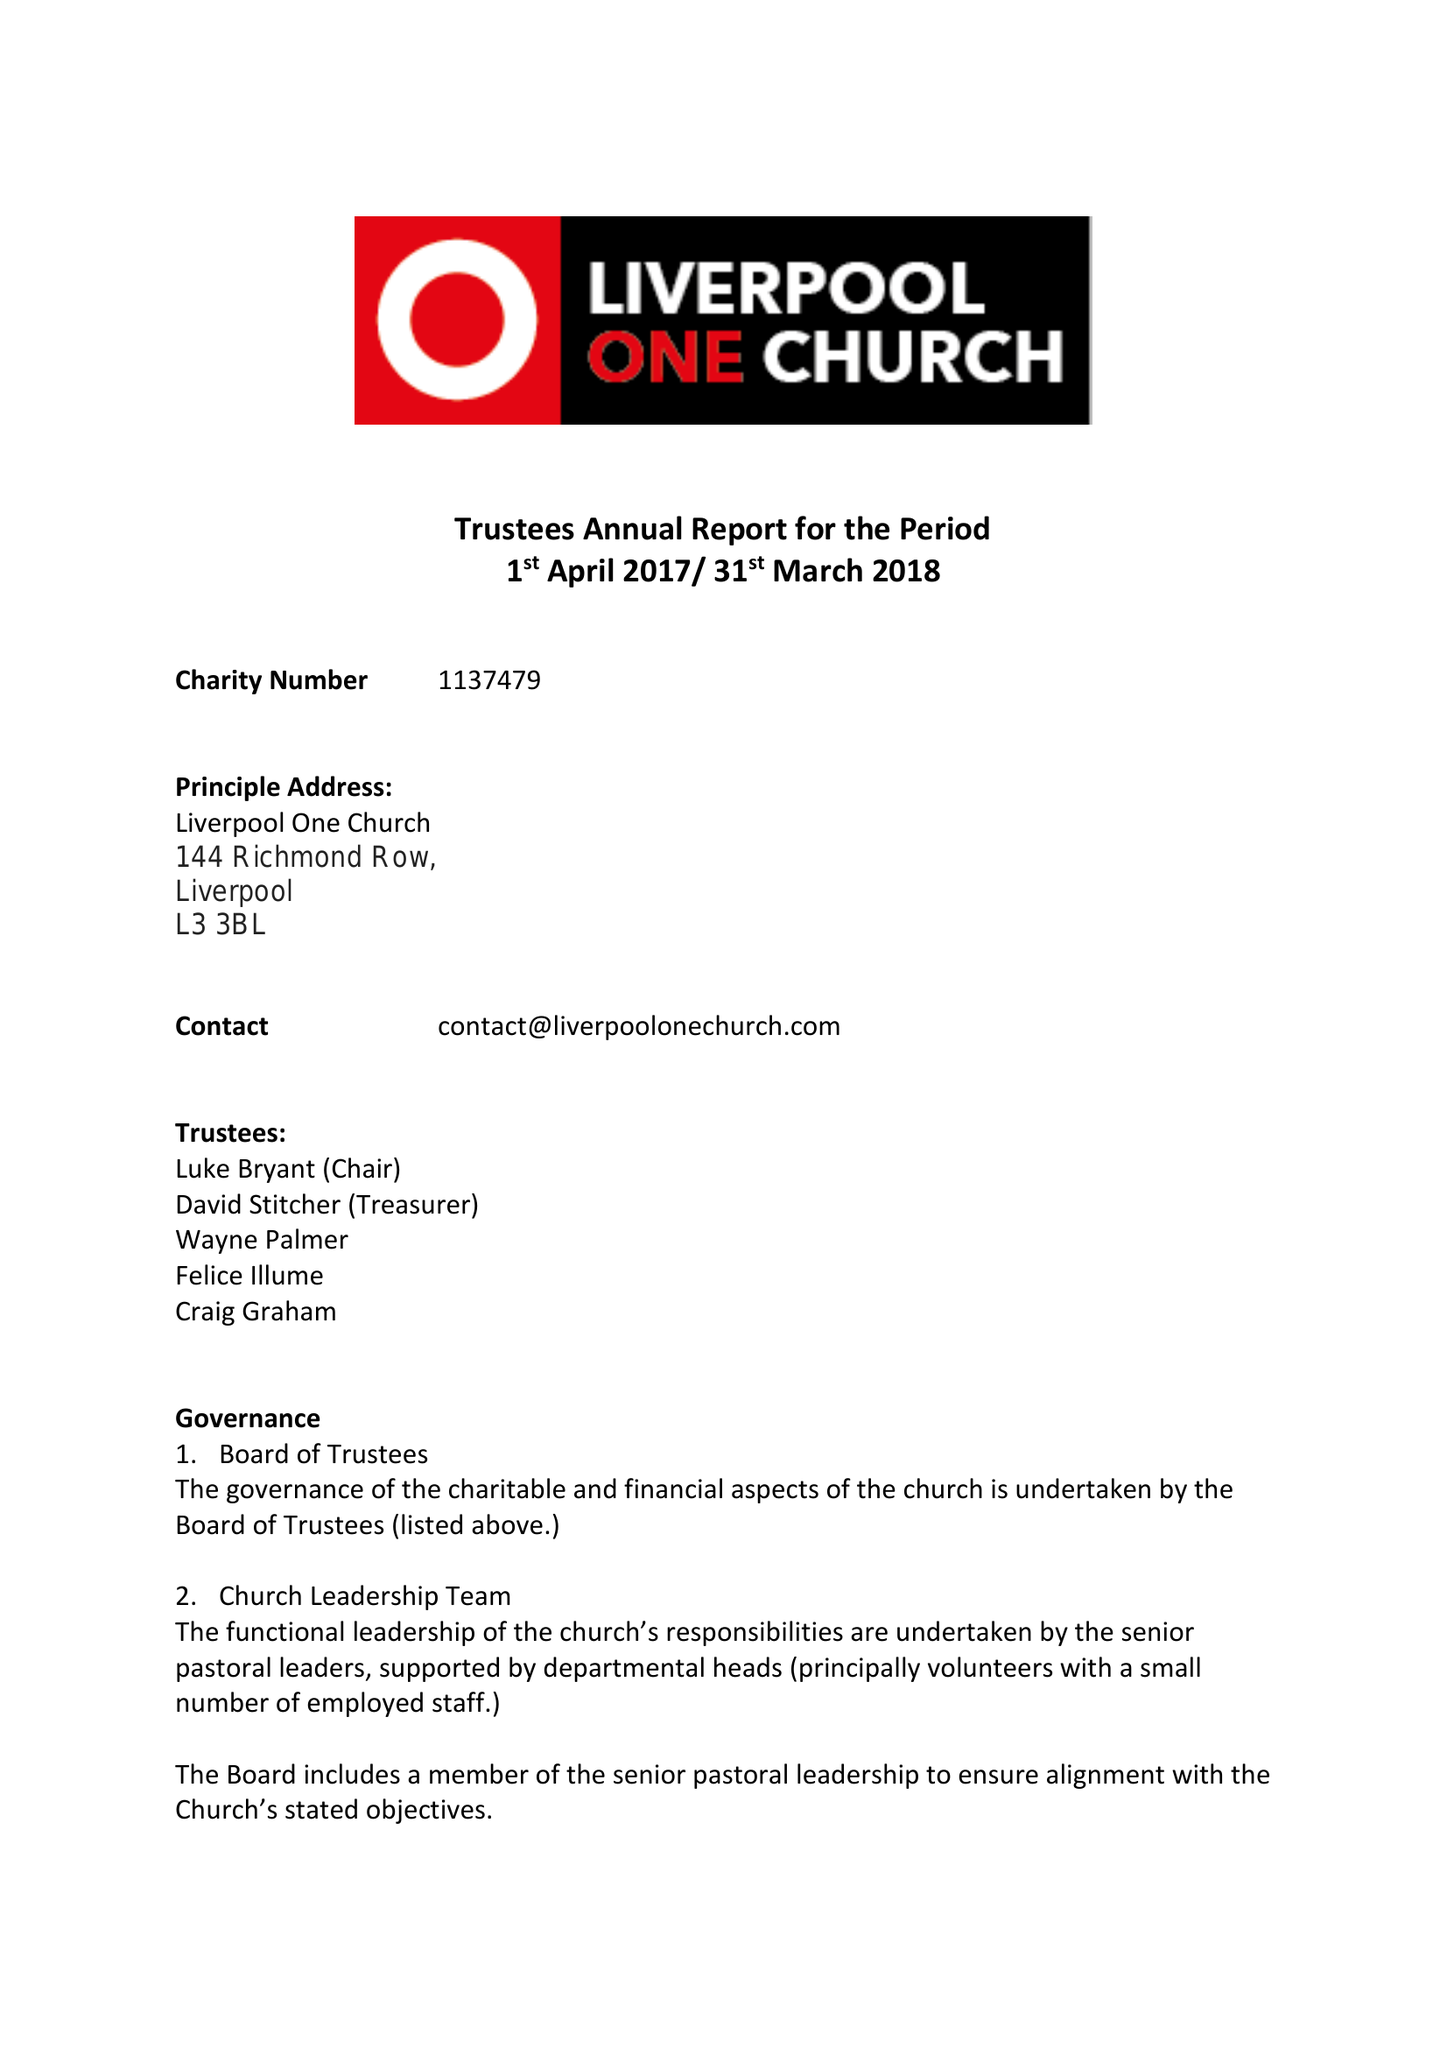What is the value for the address__postcode?
Answer the question using a single word or phrase. L3 3BL 